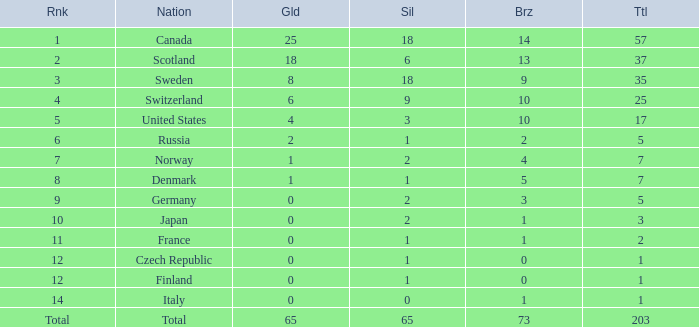What is the lowest total when the rank is 14 and the gold medals is larger than 0? None. 